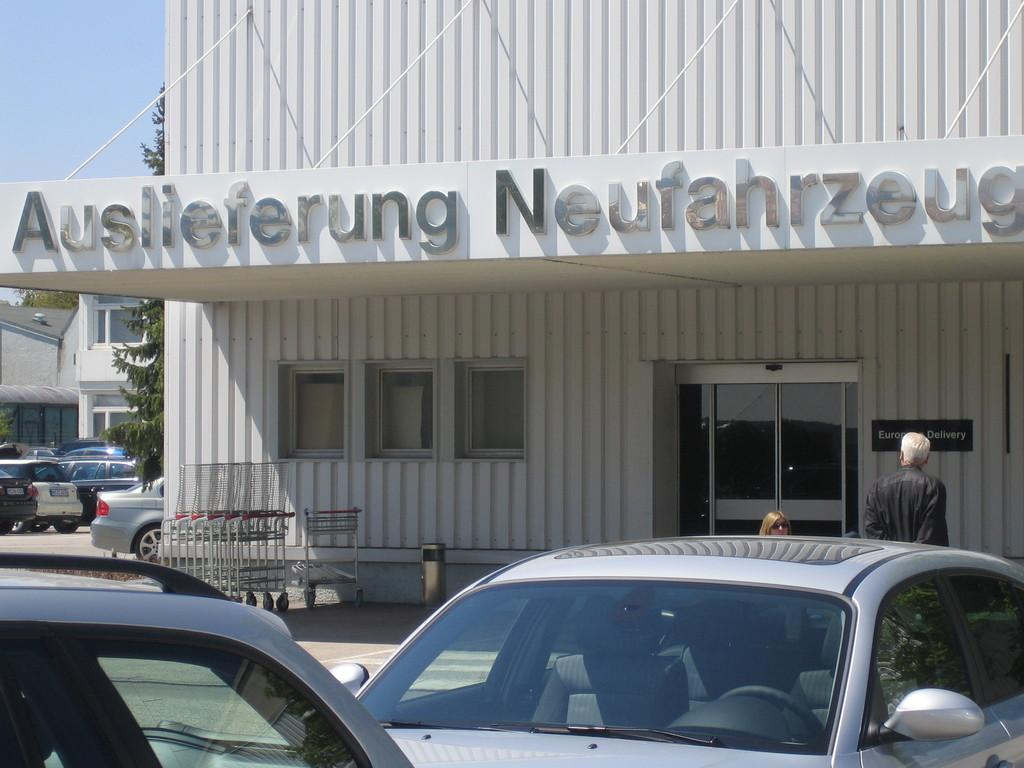What is the main structure in the image? There is a building in the image. Can you describe the person in the image? There is a person standing in front of the building. What type of vehicles can be seen in the image? There are cars in the image. What is visible above the building and cars? There is a sky visible in the image. What object is in front of the building? There is an object in front of the building. Where is the nest located in the image? There is no nest present in the image. What type of scarecrow can be seen in the image? There is no scarecrow present in the image. 